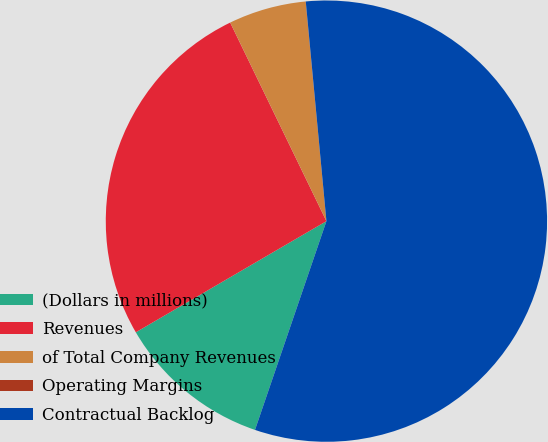Convert chart to OTSL. <chart><loc_0><loc_0><loc_500><loc_500><pie_chart><fcel>(Dollars in millions)<fcel>Revenues<fcel>of Total Company Revenues<fcel>Operating Margins<fcel>Contractual Backlog<nl><fcel>11.35%<fcel>26.22%<fcel>5.68%<fcel>0.01%<fcel>56.74%<nl></chart> 